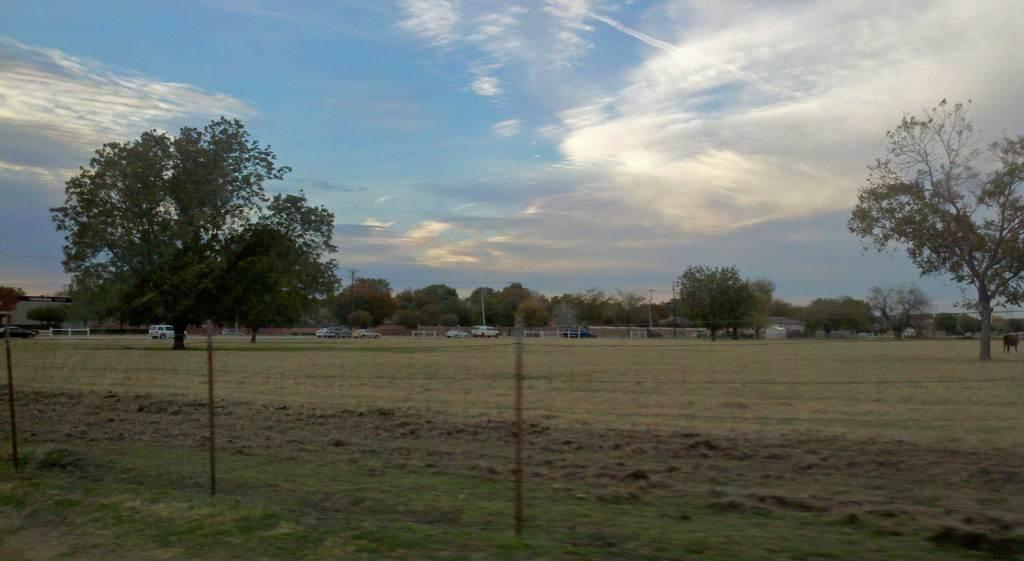Can you describe this image briefly? In the foreground of the image there is net. In the background of the image there are trees, cars, sky, clouds. At the bottom of the image there is grass. 